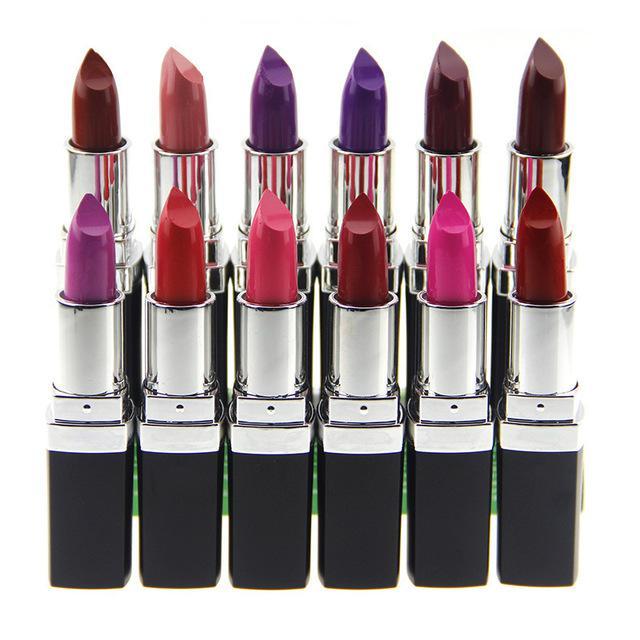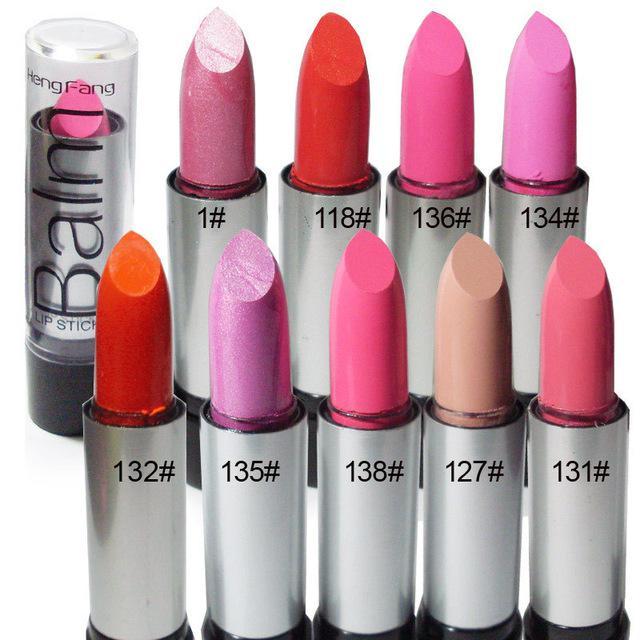The first image is the image on the left, the second image is the image on the right. Assess this claim about the two images: "The image to the left contains exactly 6 lipsticks.". Correct or not? Answer yes or no. No. 